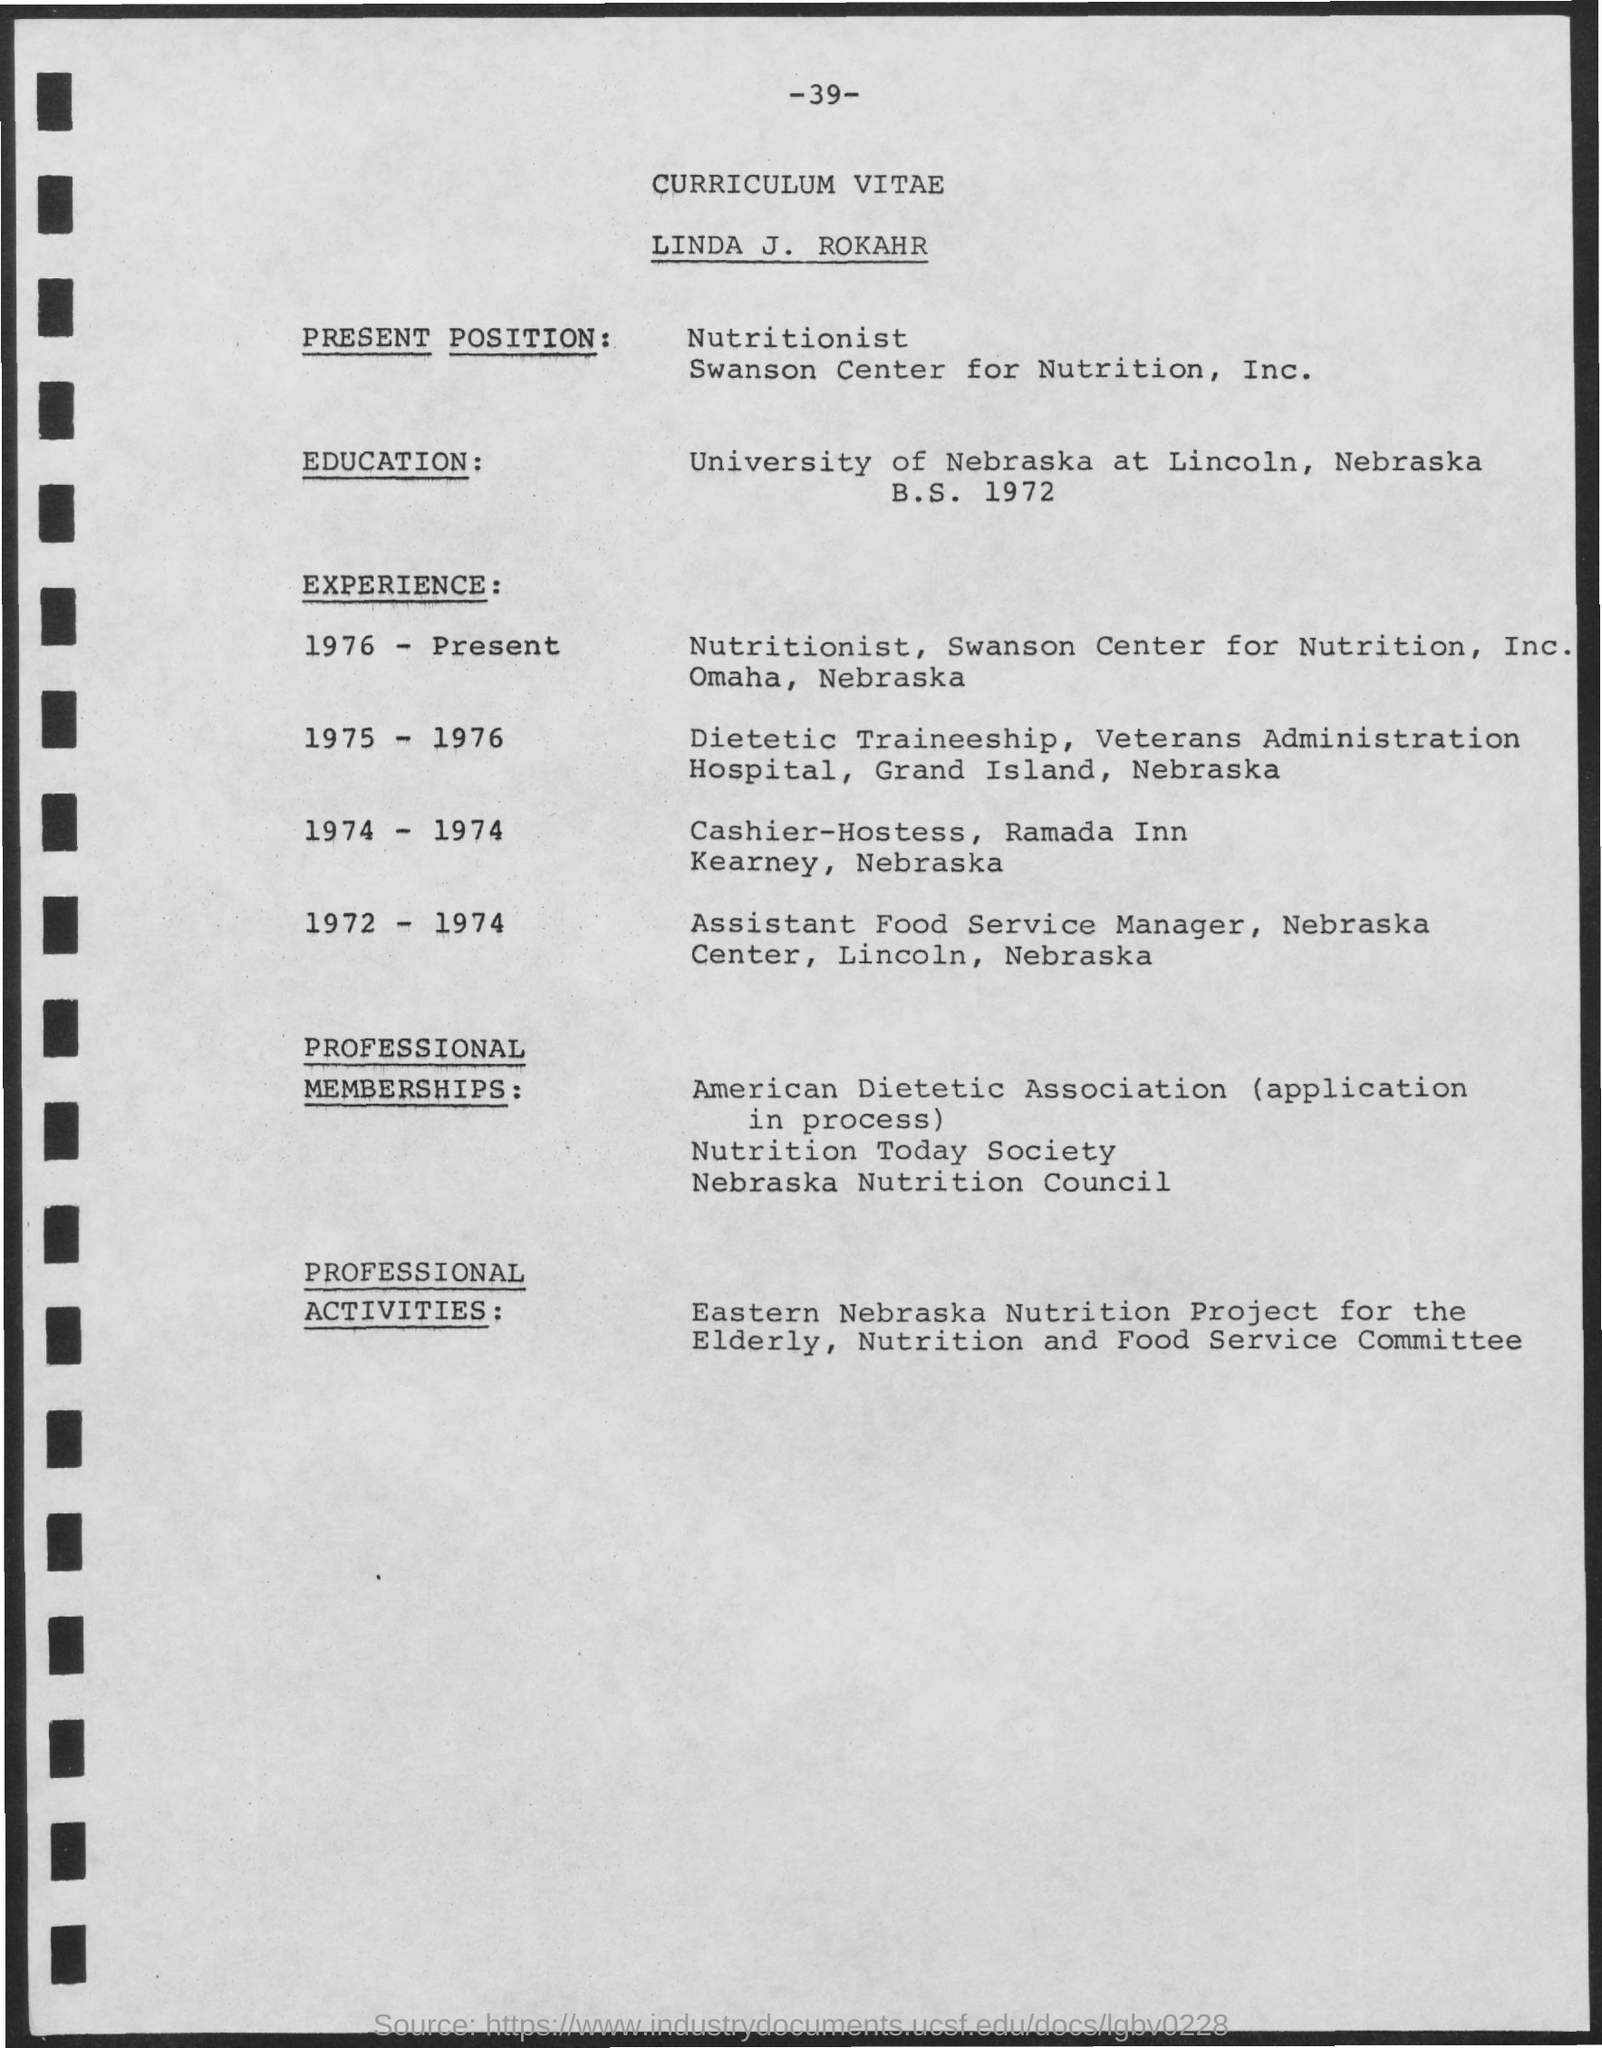Mention a couple of crucial points in this snapshot. He received his education at the University of Nebraska at Lincoln, Nebraska. Linda J. Rokahr's current position is that of a nutritionist. The title at the top of the page is 'Curriculum Vitae.' The page number mentioned on top is 39. 